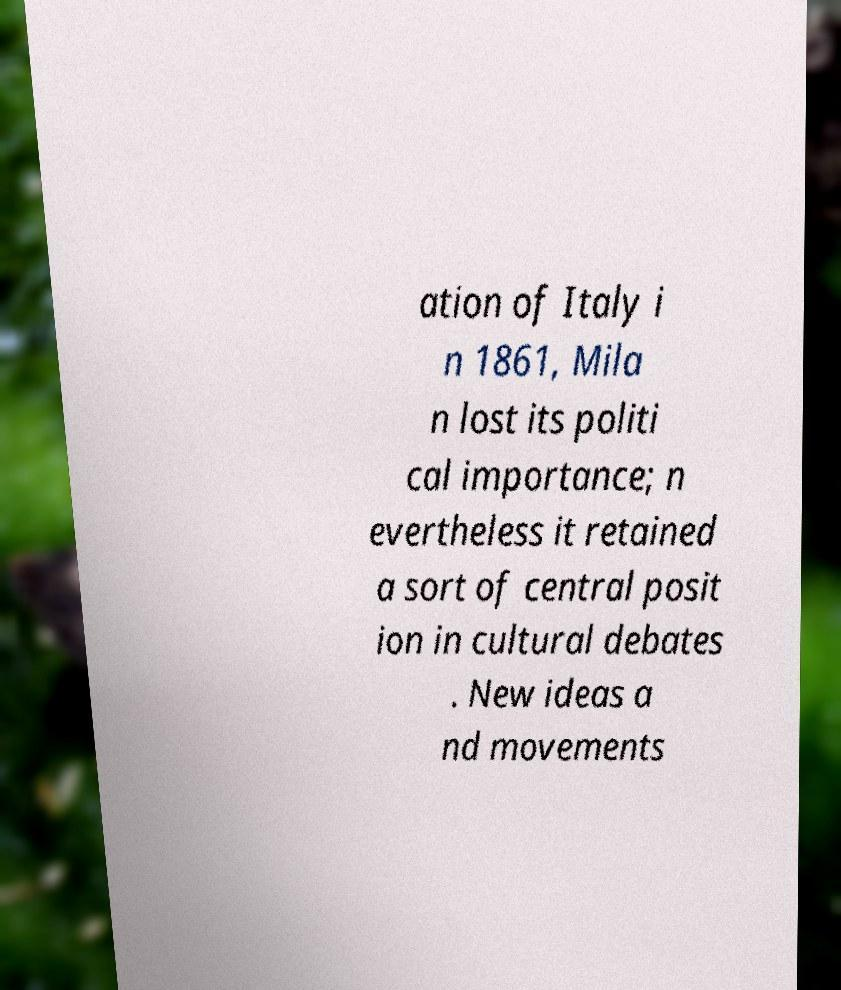For documentation purposes, I need the text within this image transcribed. Could you provide that? ation of Italy i n 1861, Mila n lost its politi cal importance; n evertheless it retained a sort of central posit ion in cultural debates . New ideas a nd movements 